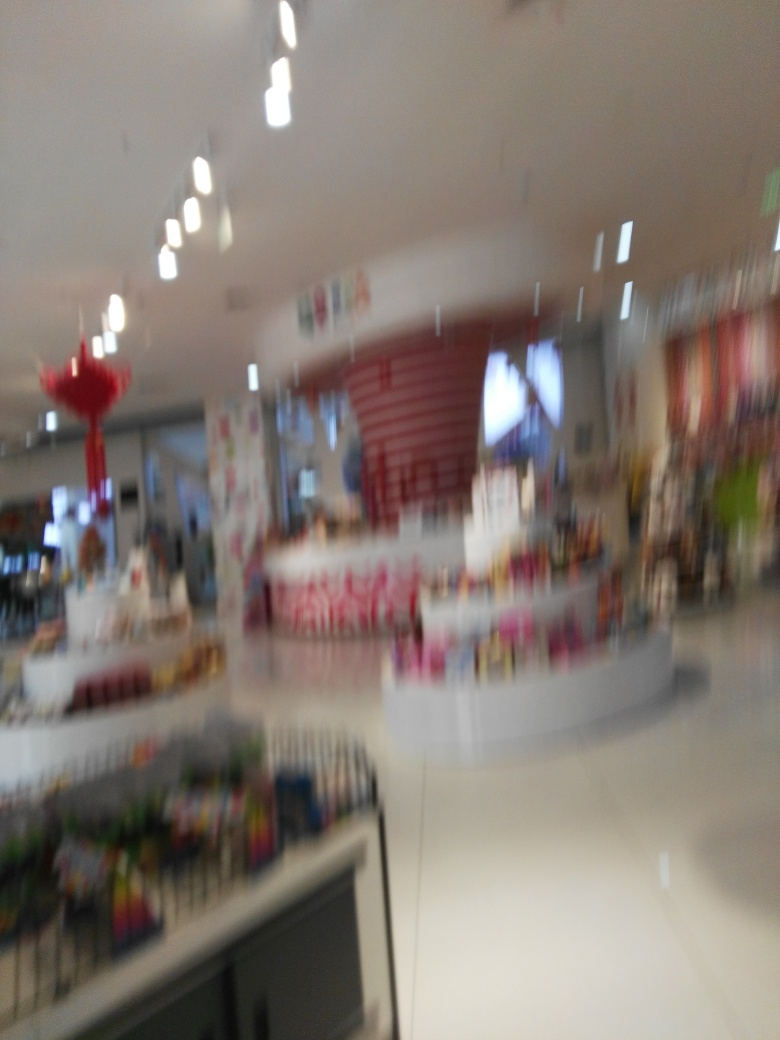Can you guess what time of day it might be based on the lighting in this image? Given the bright artificial lighting visible in the image, it is difficult to ascertain the exact time of day. However, the fact that the lights are on and the space appears to be in use suggests it could be during business hours. 